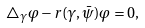Convert formula to latex. <formula><loc_0><loc_0><loc_500><loc_500>\triangle _ { \gamma } \varphi - r ( \gamma , \bar { \psi } ) \varphi = 0 ,</formula> 